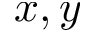Convert formula to latex. <formula><loc_0><loc_0><loc_500><loc_500>x , y</formula> 